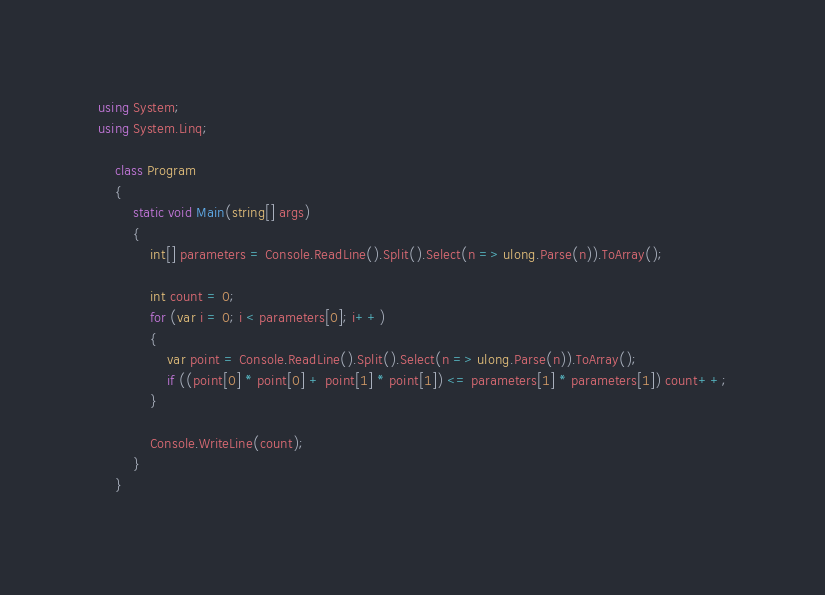<code> <loc_0><loc_0><loc_500><loc_500><_C#_>using System;
using System.Linq;

    class Program
    {
        static void Main(string[] args)
        {
            int[] parameters = Console.ReadLine().Split().Select(n => ulong.Parse(n)).ToArray();

            int count = 0;
            for (var i = 0; i < parameters[0]; i++)
            {
                var point = Console.ReadLine().Split().Select(n => ulong.Parse(n)).ToArray();
                if ((point[0] * point[0] + point[1] * point[1]) <= parameters[1] * parameters[1]) count++;
            }

            Console.WriteLine(count);
        }
    }
</code> 